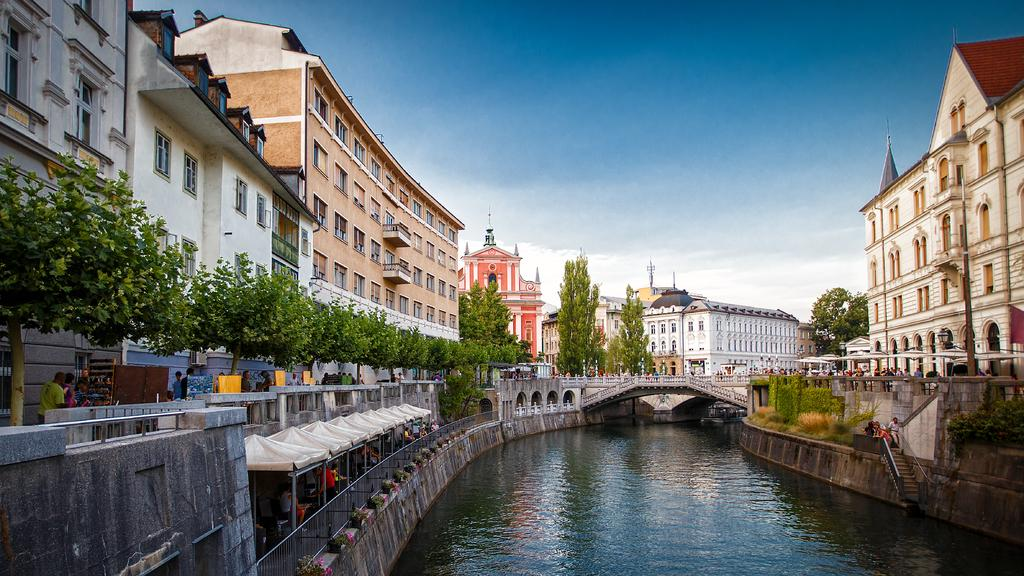What type of water feature is present in the image? There is a canal in the image. How is the canal crossed in the image? There is a bridge over the canal in the image. What type of vegetation can be seen in the image? There are trees and plants in the image. What type of structures are visible in the image? There are buildings in the image. image. Are there any other people present in the image? Yes, there are other people in the image. What type of mice can be seen running along the bridge in the image? There are no mice present in the image. What type of liquid is being used for writing on the buildings in the image? There is no writing on the buildings in the image, and therefore no liquid is being used for writing. 